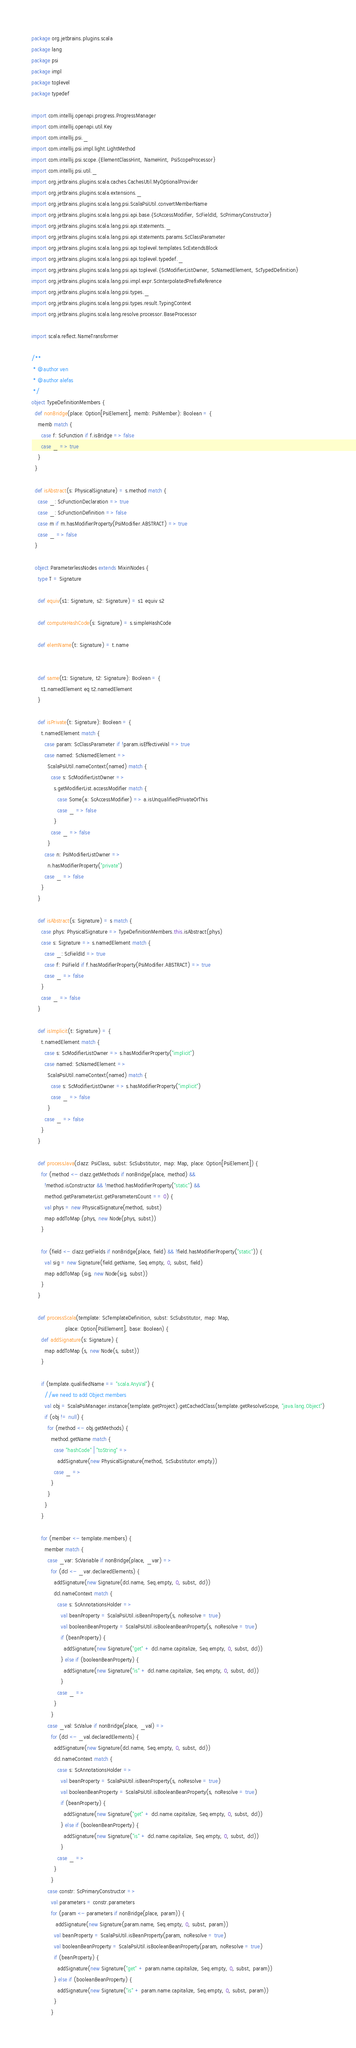Convert code to text. <code><loc_0><loc_0><loc_500><loc_500><_Scala_>package org.jetbrains.plugins.scala
package lang
package psi
package impl
package toplevel
package typedef

import com.intellij.openapi.progress.ProgressManager
import com.intellij.openapi.util.Key
import com.intellij.psi._
import com.intellij.psi.impl.light.LightMethod
import com.intellij.psi.scope.{ElementClassHint, NameHint, PsiScopeProcessor}
import com.intellij.psi.util._
import org.jetbrains.plugins.scala.caches.CachesUtil.MyOptionalProvider
import org.jetbrains.plugins.scala.extensions._
import org.jetbrains.plugins.scala.lang.psi.ScalaPsiUtil.convertMemberName
import org.jetbrains.plugins.scala.lang.psi.api.base.{ScAccessModifier, ScFieldId, ScPrimaryConstructor}
import org.jetbrains.plugins.scala.lang.psi.api.statements._
import org.jetbrains.plugins.scala.lang.psi.api.statements.params.ScClassParameter
import org.jetbrains.plugins.scala.lang.psi.api.toplevel.templates.ScExtendsBlock
import org.jetbrains.plugins.scala.lang.psi.api.toplevel.typedef._
import org.jetbrains.plugins.scala.lang.psi.api.toplevel.{ScModifierListOwner, ScNamedElement, ScTypedDefinition}
import org.jetbrains.plugins.scala.lang.psi.impl.expr.ScInterpolatedPrefixReference
import org.jetbrains.plugins.scala.lang.psi.types._
import org.jetbrains.plugins.scala.lang.psi.types.result.TypingContext
import org.jetbrains.plugins.scala.lang.resolve.processor.BaseProcessor

import scala.reflect.NameTransformer

/**
 * @author ven
 * @author alefas
 */
object TypeDefinitionMembers {
  def nonBridge(place: Option[PsiElement], memb: PsiMember): Boolean = {
    memb match {
      case f: ScFunction if f.isBridge => false
      case _ => true
    }
  }

  def isAbstract(s: PhysicalSignature) = s.method match {
    case _: ScFunctionDeclaration => true
    case _: ScFunctionDefinition => false
    case m if m.hasModifierProperty(PsiModifier.ABSTRACT) => true
    case _ => false
  }

  object ParameterlessNodes extends MixinNodes {
    type T = Signature

    def equiv(s1: Signature, s2: Signature) = s1 equiv s2

    def computeHashCode(s: Signature) = s.simpleHashCode

    def elemName(t: Signature) = t.name


    def same(t1: Signature, t2: Signature): Boolean = {
      t1.namedElement eq t2.namedElement
    }

    def isPrivate(t: Signature): Boolean = {
      t.namedElement match {
        case param: ScClassParameter if !param.isEffectiveVal => true
        case named: ScNamedElement =>
          ScalaPsiUtil.nameContext(named) match {
            case s: ScModifierListOwner =>
              s.getModifierList.accessModifier match {
                case Some(a: ScAccessModifier) => a.isUnqualifiedPrivateOrThis
                case _ => false
              }
            case _ => false
          }
        case n: PsiModifierListOwner =>
          n.hasModifierProperty("private")
        case _ => false
      }
    }

    def isAbstract(s: Signature) = s match {
      case phys: PhysicalSignature => TypeDefinitionMembers.this.isAbstract(phys)
      case s: Signature => s.namedElement match {
        case _: ScFieldId => true
        case f: PsiField if f.hasModifierProperty(PsiModifier.ABSTRACT) => true
        case _ => false
      }
      case _ => false
    }

    def isImplicit(t: Signature) = {
      t.namedElement match {
        case s: ScModifierListOwner => s.hasModifierProperty("implicit")
        case named: ScNamedElement =>
          ScalaPsiUtil.nameContext(named) match {
            case s: ScModifierListOwner => s.hasModifierProperty("implicit")
            case _ => false
          }
        case _ => false
      }
    }

    def processJava(clazz: PsiClass, subst: ScSubstitutor, map: Map, place: Option[PsiElement]) {
      for (method <- clazz.getMethods if nonBridge(place, method) &&
        !method.isConstructor && !method.hasModifierProperty("static") &&
        method.getParameterList.getParametersCount == 0) {
        val phys = new PhysicalSignature(method, subst)
        map addToMap (phys, new Node(phys, subst))
      }

      for (field <- clazz.getFields if nonBridge(place, field) && !field.hasModifierProperty("static")) {
        val sig = new Signature(field.getName, Seq.empty, 0, subst, field)
        map addToMap (sig, new Node(sig, subst))
      }
    }

    def processScala(template: ScTemplateDefinition, subst: ScSubstitutor, map: Map,
                     place: Option[PsiElement], base: Boolean) {
      def addSignature(s: Signature) {
        map addToMap (s, new Node(s, subst))
      }

      if (template.qualifiedName == "scala.AnyVal") {
        //we need to add Object members
        val obj = ScalaPsiManager.instance(template.getProject).getCachedClass(template.getResolveScope, "java.lang.Object")
        if (obj != null) {
          for (method <- obj.getMethods) {
            method.getName match {
              case "hashCode" | "toString" =>
                addSignature(new PhysicalSignature(method, ScSubstitutor.empty))
              case _ =>
            }
          }
        }
      }

      for (member <- template.members) {
        member match {
          case _var: ScVariable if nonBridge(place, _var) =>
            for (dcl <- _var.declaredElements) {
              addSignature(new Signature(dcl.name, Seq.empty, 0, subst, dcl))
              dcl.nameContext match {
                case s: ScAnnotationsHolder =>
                  val beanProperty = ScalaPsiUtil.isBeanProperty(s, noResolve = true)
                  val booleanBeanProperty = ScalaPsiUtil.isBooleanBeanProperty(s, noResolve = true)
                  if (beanProperty) {
                    addSignature(new Signature("get" + dcl.name.capitalize, Seq.empty, 0, subst, dcl))
                  } else if (booleanBeanProperty) {
                    addSignature(new Signature("is" + dcl.name.capitalize, Seq.empty, 0, subst, dcl))
                  }
                case _ =>
              }
            }
          case _val: ScValue if nonBridge(place, _val) =>
            for (dcl <- _val.declaredElements) {
              addSignature(new Signature(dcl.name, Seq.empty, 0, subst, dcl))
              dcl.nameContext match {
                case s: ScAnnotationsHolder =>
                  val beanProperty = ScalaPsiUtil.isBeanProperty(s, noResolve = true)
                  val booleanBeanProperty = ScalaPsiUtil.isBooleanBeanProperty(s, noResolve = true)
                  if (beanProperty) {
                    addSignature(new Signature("get" + dcl.name.capitalize, Seq.empty, 0, subst, dcl))
                  } else if (booleanBeanProperty) {
                    addSignature(new Signature("is" + dcl.name.capitalize, Seq.empty, 0, subst, dcl))
                  }
                case _ =>
              }
            }
          case constr: ScPrimaryConstructor =>
            val parameters = constr.parameters
            for (param <- parameters if nonBridge(place, param)) {
               addSignature(new Signature(param.name, Seq.empty, 0, subst, param))
              val beanProperty = ScalaPsiUtil.isBeanProperty(param, noResolve = true)
              val booleanBeanProperty = ScalaPsiUtil.isBooleanBeanProperty(param, noResolve = true)
              if (beanProperty) {
                addSignature(new Signature("get" + param.name.capitalize, Seq.empty, 0, subst, param))
              } else if (booleanBeanProperty) {
                addSignature(new Signature("is" + param.name.capitalize, Seq.empty, 0, subst, param))
              }
            }</code> 